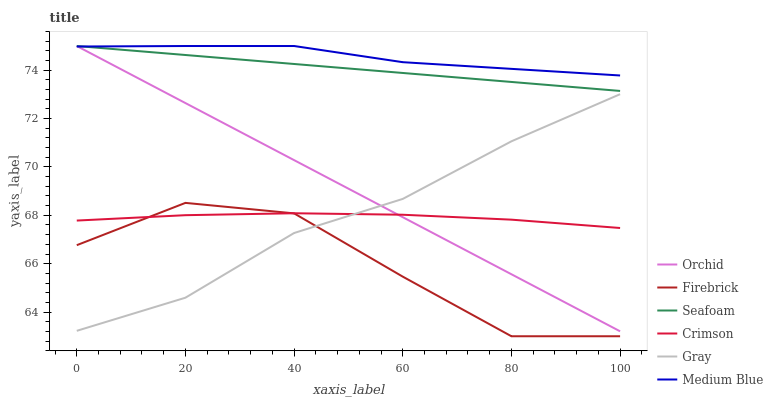Does Firebrick have the minimum area under the curve?
Answer yes or no. Yes. Does Medium Blue have the maximum area under the curve?
Answer yes or no. Yes. Does Medium Blue have the minimum area under the curve?
Answer yes or no. No. Does Firebrick have the maximum area under the curve?
Answer yes or no. No. Is Orchid the smoothest?
Answer yes or no. Yes. Is Firebrick the roughest?
Answer yes or no. Yes. Is Medium Blue the smoothest?
Answer yes or no. No. Is Medium Blue the roughest?
Answer yes or no. No. Does Firebrick have the lowest value?
Answer yes or no. Yes. Does Medium Blue have the lowest value?
Answer yes or no. No. Does Orchid have the highest value?
Answer yes or no. Yes. Does Firebrick have the highest value?
Answer yes or no. No. Is Firebrick less than Medium Blue?
Answer yes or no. Yes. Is Seafoam greater than Firebrick?
Answer yes or no. Yes. Does Gray intersect Orchid?
Answer yes or no. Yes. Is Gray less than Orchid?
Answer yes or no. No. Is Gray greater than Orchid?
Answer yes or no. No. Does Firebrick intersect Medium Blue?
Answer yes or no. No. 